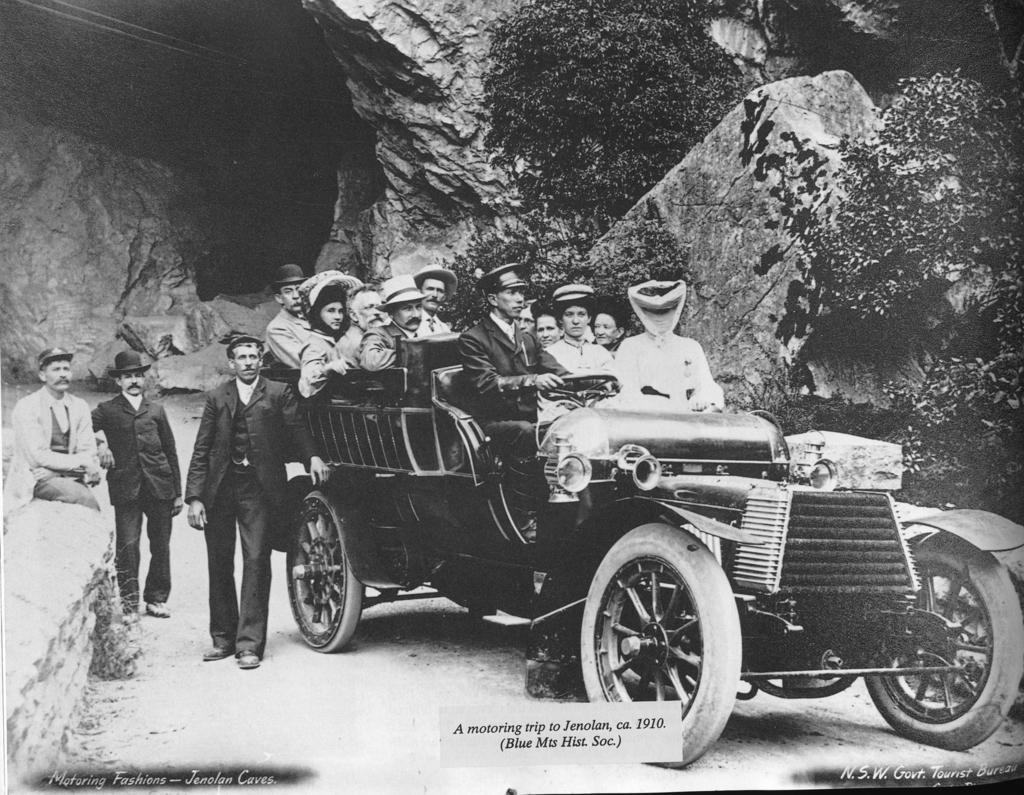How would you summarize this image in a sentence or two? This is a black and white picture. Here we can see group of people on the vehicle. In the background we can see rocks and trees. 